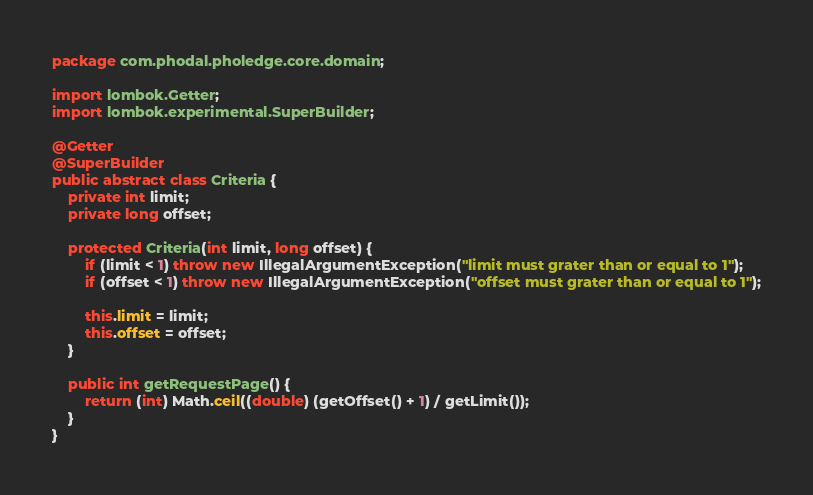<code> <loc_0><loc_0><loc_500><loc_500><_Java_>package com.phodal.pholedge.core.domain;

import lombok.Getter;
import lombok.experimental.SuperBuilder;

@Getter
@SuperBuilder
public abstract class Criteria {
    private int limit;
    private long offset;

    protected Criteria(int limit, long offset) {
        if (limit < 1) throw new IllegalArgumentException("limit must grater than or equal to 1");
        if (offset < 1) throw new IllegalArgumentException("offset must grater than or equal to 1");

        this.limit = limit;
        this.offset = offset;
    }

    public int getRequestPage() {
        return (int) Math.ceil((double) (getOffset() + 1) / getLimit());
    }
}
</code> 